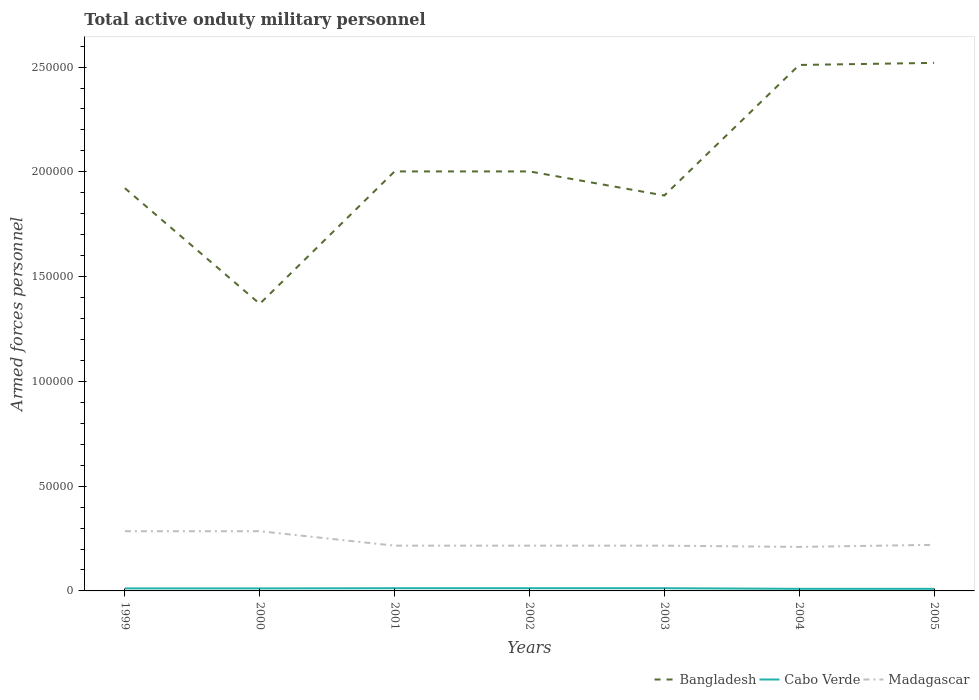Is the number of lines equal to the number of legend labels?
Keep it short and to the point. Yes. Across all years, what is the maximum number of armed forces personnel in Bangladesh?
Ensure brevity in your answer.  1.37e+05. What is the total number of armed forces personnel in Bangladesh in the graph?
Provide a short and direct response. -5.18e+04. What is the difference between the highest and the second highest number of armed forces personnel in Madagascar?
Keep it short and to the point. 7500. Is the number of armed forces personnel in Madagascar strictly greater than the number of armed forces personnel in Bangladesh over the years?
Your answer should be compact. Yes. How many lines are there?
Make the answer very short. 3. How many years are there in the graph?
Provide a succinct answer. 7. What is the difference between two consecutive major ticks on the Y-axis?
Provide a succinct answer. 5.00e+04. How many legend labels are there?
Keep it short and to the point. 3. What is the title of the graph?
Offer a terse response. Total active onduty military personnel. Does "Uganda" appear as one of the legend labels in the graph?
Ensure brevity in your answer.  No. What is the label or title of the Y-axis?
Offer a terse response. Armed forces personnel. What is the Armed forces personnel in Bangladesh in 1999?
Keep it short and to the point. 1.92e+05. What is the Armed forces personnel in Cabo Verde in 1999?
Your response must be concise. 1200. What is the Armed forces personnel of Madagascar in 1999?
Give a very brief answer. 2.85e+04. What is the Armed forces personnel in Bangladesh in 2000?
Offer a terse response. 1.37e+05. What is the Armed forces personnel in Cabo Verde in 2000?
Your answer should be compact. 1200. What is the Armed forces personnel in Madagascar in 2000?
Give a very brief answer. 2.85e+04. What is the Armed forces personnel in Bangladesh in 2001?
Provide a short and direct response. 2.00e+05. What is the Armed forces personnel of Cabo Verde in 2001?
Offer a very short reply. 1300. What is the Armed forces personnel in Madagascar in 2001?
Your answer should be compact. 2.16e+04. What is the Armed forces personnel of Bangladesh in 2002?
Make the answer very short. 2.00e+05. What is the Armed forces personnel of Cabo Verde in 2002?
Your answer should be compact. 1300. What is the Armed forces personnel of Madagascar in 2002?
Your answer should be compact. 2.16e+04. What is the Armed forces personnel in Bangladesh in 2003?
Your answer should be compact. 1.89e+05. What is the Armed forces personnel in Cabo Verde in 2003?
Keep it short and to the point. 1300. What is the Armed forces personnel of Madagascar in 2003?
Your response must be concise. 2.16e+04. What is the Armed forces personnel of Bangladesh in 2004?
Ensure brevity in your answer.  2.51e+05. What is the Armed forces personnel in Cabo Verde in 2004?
Ensure brevity in your answer.  1000. What is the Armed forces personnel of Madagascar in 2004?
Make the answer very short. 2.10e+04. What is the Armed forces personnel in Bangladesh in 2005?
Provide a succinct answer. 2.52e+05. What is the Armed forces personnel in Madagascar in 2005?
Your answer should be compact. 2.20e+04. Across all years, what is the maximum Armed forces personnel of Bangladesh?
Make the answer very short. 2.52e+05. Across all years, what is the maximum Armed forces personnel of Cabo Verde?
Your answer should be compact. 1300. Across all years, what is the maximum Armed forces personnel in Madagascar?
Offer a terse response. 2.85e+04. Across all years, what is the minimum Armed forces personnel in Bangladesh?
Provide a short and direct response. 1.37e+05. Across all years, what is the minimum Armed forces personnel in Madagascar?
Your answer should be very brief. 2.10e+04. What is the total Armed forces personnel in Bangladesh in the graph?
Make the answer very short. 1.42e+06. What is the total Armed forces personnel of Cabo Verde in the graph?
Your answer should be compact. 8300. What is the total Armed forces personnel in Madagascar in the graph?
Offer a very short reply. 1.65e+05. What is the difference between the Armed forces personnel of Bangladesh in 1999 and that in 2000?
Make the answer very short. 5.52e+04. What is the difference between the Armed forces personnel in Cabo Verde in 1999 and that in 2000?
Offer a terse response. 0. What is the difference between the Armed forces personnel of Madagascar in 1999 and that in 2000?
Your answer should be very brief. 0. What is the difference between the Armed forces personnel in Bangladesh in 1999 and that in 2001?
Make the answer very short. -8000. What is the difference between the Armed forces personnel in Cabo Verde in 1999 and that in 2001?
Your response must be concise. -100. What is the difference between the Armed forces personnel in Madagascar in 1999 and that in 2001?
Give a very brief answer. 6900. What is the difference between the Armed forces personnel of Bangladesh in 1999 and that in 2002?
Provide a succinct answer. -8000. What is the difference between the Armed forces personnel in Cabo Verde in 1999 and that in 2002?
Provide a succinct answer. -100. What is the difference between the Armed forces personnel in Madagascar in 1999 and that in 2002?
Provide a short and direct response. 6900. What is the difference between the Armed forces personnel in Bangladesh in 1999 and that in 2003?
Provide a succinct answer. 3500. What is the difference between the Armed forces personnel of Cabo Verde in 1999 and that in 2003?
Offer a terse response. -100. What is the difference between the Armed forces personnel of Madagascar in 1999 and that in 2003?
Your answer should be compact. 6900. What is the difference between the Armed forces personnel of Bangladesh in 1999 and that in 2004?
Give a very brief answer. -5.88e+04. What is the difference between the Armed forces personnel in Cabo Verde in 1999 and that in 2004?
Ensure brevity in your answer.  200. What is the difference between the Armed forces personnel in Madagascar in 1999 and that in 2004?
Provide a short and direct response. 7500. What is the difference between the Armed forces personnel in Bangladesh in 1999 and that in 2005?
Your response must be concise. -5.98e+04. What is the difference between the Armed forces personnel in Cabo Verde in 1999 and that in 2005?
Keep it short and to the point. 200. What is the difference between the Armed forces personnel of Madagascar in 1999 and that in 2005?
Your answer should be compact. 6500. What is the difference between the Armed forces personnel in Bangladesh in 2000 and that in 2001?
Provide a succinct answer. -6.32e+04. What is the difference between the Armed forces personnel in Cabo Verde in 2000 and that in 2001?
Your answer should be compact. -100. What is the difference between the Armed forces personnel in Madagascar in 2000 and that in 2001?
Keep it short and to the point. 6900. What is the difference between the Armed forces personnel in Bangladesh in 2000 and that in 2002?
Offer a very short reply. -6.32e+04. What is the difference between the Armed forces personnel of Cabo Verde in 2000 and that in 2002?
Offer a very short reply. -100. What is the difference between the Armed forces personnel in Madagascar in 2000 and that in 2002?
Your response must be concise. 6900. What is the difference between the Armed forces personnel of Bangladesh in 2000 and that in 2003?
Your answer should be very brief. -5.17e+04. What is the difference between the Armed forces personnel of Cabo Verde in 2000 and that in 2003?
Your answer should be compact. -100. What is the difference between the Armed forces personnel in Madagascar in 2000 and that in 2003?
Your answer should be very brief. 6900. What is the difference between the Armed forces personnel of Bangladesh in 2000 and that in 2004?
Your answer should be compact. -1.14e+05. What is the difference between the Armed forces personnel in Cabo Verde in 2000 and that in 2004?
Offer a terse response. 200. What is the difference between the Armed forces personnel of Madagascar in 2000 and that in 2004?
Provide a succinct answer. 7500. What is the difference between the Armed forces personnel of Bangladesh in 2000 and that in 2005?
Offer a very short reply. -1.15e+05. What is the difference between the Armed forces personnel in Madagascar in 2000 and that in 2005?
Make the answer very short. 6500. What is the difference between the Armed forces personnel of Cabo Verde in 2001 and that in 2002?
Ensure brevity in your answer.  0. What is the difference between the Armed forces personnel in Madagascar in 2001 and that in 2002?
Your response must be concise. 0. What is the difference between the Armed forces personnel in Bangladesh in 2001 and that in 2003?
Offer a very short reply. 1.15e+04. What is the difference between the Armed forces personnel of Madagascar in 2001 and that in 2003?
Offer a terse response. 0. What is the difference between the Armed forces personnel of Bangladesh in 2001 and that in 2004?
Make the answer very short. -5.08e+04. What is the difference between the Armed forces personnel in Cabo Verde in 2001 and that in 2004?
Ensure brevity in your answer.  300. What is the difference between the Armed forces personnel in Madagascar in 2001 and that in 2004?
Offer a very short reply. 600. What is the difference between the Armed forces personnel of Bangladesh in 2001 and that in 2005?
Provide a succinct answer. -5.18e+04. What is the difference between the Armed forces personnel of Cabo Verde in 2001 and that in 2005?
Your answer should be very brief. 300. What is the difference between the Armed forces personnel of Madagascar in 2001 and that in 2005?
Provide a succinct answer. -400. What is the difference between the Armed forces personnel in Bangladesh in 2002 and that in 2003?
Keep it short and to the point. 1.15e+04. What is the difference between the Armed forces personnel of Madagascar in 2002 and that in 2003?
Make the answer very short. 0. What is the difference between the Armed forces personnel in Bangladesh in 2002 and that in 2004?
Your answer should be compact. -5.08e+04. What is the difference between the Armed forces personnel of Cabo Verde in 2002 and that in 2004?
Your answer should be compact. 300. What is the difference between the Armed forces personnel in Madagascar in 2002 and that in 2004?
Your response must be concise. 600. What is the difference between the Armed forces personnel in Bangladesh in 2002 and that in 2005?
Ensure brevity in your answer.  -5.18e+04. What is the difference between the Armed forces personnel of Cabo Verde in 2002 and that in 2005?
Your answer should be very brief. 300. What is the difference between the Armed forces personnel in Madagascar in 2002 and that in 2005?
Ensure brevity in your answer.  -400. What is the difference between the Armed forces personnel of Bangladesh in 2003 and that in 2004?
Your response must be concise. -6.23e+04. What is the difference between the Armed forces personnel of Cabo Verde in 2003 and that in 2004?
Offer a terse response. 300. What is the difference between the Armed forces personnel in Madagascar in 2003 and that in 2004?
Keep it short and to the point. 600. What is the difference between the Armed forces personnel in Bangladesh in 2003 and that in 2005?
Offer a very short reply. -6.33e+04. What is the difference between the Armed forces personnel in Cabo Verde in 2003 and that in 2005?
Your response must be concise. 300. What is the difference between the Armed forces personnel in Madagascar in 2003 and that in 2005?
Make the answer very short. -400. What is the difference between the Armed forces personnel in Bangladesh in 2004 and that in 2005?
Your answer should be compact. -1000. What is the difference between the Armed forces personnel in Madagascar in 2004 and that in 2005?
Ensure brevity in your answer.  -1000. What is the difference between the Armed forces personnel in Bangladesh in 1999 and the Armed forces personnel in Cabo Verde in 2000?
Make the answer very short. 1.91e+05. What is the difference between the Armed forces personnel in Bangladesh in 1999 and the Armed forces personnel in Madagascar in 2000?
Ensure brevity in your answer.  1.64e+05. What is the difference between the Armed forces personnel in Cabo Verde in 1999 and the Armed forces personnel in Madagascar in 2000?
Offer a terse response. -2.73e+04. What is the difference between the Armed forces personnel of Bangladesh in 1999 and the Armed forces personnel of Cabo Verde in 2001?
Your answer should be very brief. 1.91e+05. What is the difference between the Armed forces personnel of Bangladesh in 1999 and the Armed forces personnel of Madagascar in 2001?
Your response must be concise. 1.71e+05. What is the difference between the Armed forces personnel in Cabo Verde in 1999 and the Armed forces personnel in Madagascar in 2001?
Provide a succinct answer. -2.04e+04. What is the difference between the Armed forces personnel of Bangladesh in 1999 and the Armed forces personnel of Cabo Verde in 2002?
Your answer should be compact. 1.91e+05. What is the difference between the Armed forces personnel in Bangladesh in 1999 and the Armed forces personnel in Madagascar in 2002?
Offer a very short reply. 1.71e+05. What is the difference between the Armed forces personnel of Cabo Verde in 1999 and the Armed forces personnel of Madagascar in 2002?
Your response must be concise. -2.04e+04. What is the difference between the Armed forces personnel of Bangladesh in 1999 and the Armed forces personnel of Cabo Verde in 2003?
Your response must be concise. 1.91e+05. What is the difference between the Armed forces personnel in Bangladesh in 1999 and the Armed forces personnel in Madagascar in 2003?
Give a very brief answer. 1.71e+05. What is the difference between the Armed forces personnel in Cabo Verde in 1999 and the Armed forces personnel in Madagascar in 2003?
Keep it short and to the point. -2.04e+04. What is the difference between the Armed forces personnel in Bangladesh in 1999 and the Armed forces personnel in Cabo Verde in 2004?
Keep it short and to the point. 1.91e+05. What is the difference between the Armed forces personnel of Bangladesh in 1999 and the Armed forces personnel of Madagascar in 2004?
Make the answer very short. 1.71e+05. What is the difference between the Armed forces personnel of Cabo Verde in 1999 and the Armed forces personnel of Madagascar in 2004?
Make the answer very short. -1.98e+04. What is the difference between the Armed forces personnel of Bangladesh in 1999 and the Armed forces personnel of Cabo Verde in 2005?
Keep it short and to the point. 1.91e+05. What is the difference between the Armed forces personnel of Bangladesh in 1999 and the Armed forces personnel of Madagascar in 2005?
Provide a succinct answer. 1.70e+05. What is the difference between the Armed forces personnel of Cabo Verde in 1999 and the Armed forces personnel of Madagascar in 2005?
Keep it short and to the point. -2.08e+04. What is the difference between the Armed forces personnel in Bangladesh in 2000 and the Armed forces personnel in Cabo Verde in 2001?
Your response must be concise. 1.36e+05. What is the difference between the Armed forces personnel in Bangladesh in 2000 and the Armed forces personnel in Madagascar in 2001?
Make the answer very short. 1.15e+05. What is the difference between the Armed forces personnel in Cabo Verde in 2000 and the Armed forces personnel in Madagascar in 2001?
Your answer should be very brief. -2.04e+04. What is the difference between the Armed forces personnel in Bangladesh in 2000 and the Armed forces personnel in Cabo Verde in 2002?
Keep it short and to the point. 1.36e+05. What is the difference between the Armed forces personnel in Bangladesh in 2000 and the Armed forces personnel in Madagascar in 2002?
Offer a very short reply. 1.15e+05. What is the difference between the Armed forces personnel of Cabo Verde in 2000 and the Armed forces personnel of Madagascar in 2002?
Offer a terse response. -2.04e+04. What is the difference between the Armed forces personnel of Bangladesh in 2000 and the Armed forces personnel of Cabo Verde in 2003?
Ensure brevity in your answer.  1.36e+05. What is the difference between the Armed forces personnel in Bangladesh in 2000 and the Armed forces personnel in Madagascar in 2003?
Your response must be concise. 1.15e+05. What is the difference between the Armed forces personnel in Cabo Verde in 2000 and the Armed forces personnel in Madagascar in 2003?
Your answer should be compact. -2.04e+04. What is the difference between the Armed forces personnel of Bangladesh in 2000 and the Armed forces personnel of Cabo Verde in 2004?
Make the answer very short. 1.36e+05. What is the difference between the Armed forces personnel of Bangladesh in 2000 and the Armed forces personnel of Madagascar in 2004?
Your answer should be very brief. 1.16e+05. What is the difference between the Armed forces personnel in Cabo Verde in 2000 and the Armed forces personnel in Madagascar in 2004?
Keep it short and to the point. -1.98e+04. What is the difference between the Armed forces personnel of Bangladesh in 2000 and the Armed forces personnel of Cabo Verde in 2005?
Your answer should be compact. 1.36e+05. What is the difference between the Armed forces personnel of Bangladesh in 2000 and the Armed forces personnel of Madagascar in 2005?
Provide a short and direct response. 1.15e+05. What is the difference between the Armed forces personnel of Cabo Verde in 2000 and the Armed forces personnel of Madagascar in 2005?
Offer a terse response. -2.08e+04. What is the difference between the Armed forces personnel in Bangladesh in 2001 and the Armed forces personnel in Cabo Verde in 2002?
Your answer should be very brief. 1.99e+05. What is the difference between the Armed forces personnel of Bangladesh in 2001 and the Armed forces personnel of Madagascar in 2002?
Your answer should be very brief. 1.79e+05. What is the difference between the Armed forces personnel in Cabo Verde in 2001 and the Armed forces personnel in Madagascar in 2002?
Keep it short and to the point. -2.03e+04. What is the difference between the Armed forces personnel of Bangladesh in 2001 and the Armed forces personnel of Cabo Verde in 2003?
Give a very brief answer. 1.99e+05. What is the difference between the Armed forces personnel of Bangladesh in 2001 and the Armed forces personnel of Madagascar in 2003?
Offer a terse response. 1.79e+05. What is the difference between the Armed forces personnel of Cabo Verde in 2001 and the Armed forces personnel of Madagascar in 2003?
Provide a succinct answer. -2.03e+04. What is the difference between the Armed forces personnel of Bangladesh in 2001 and the Armed forces personnel of Cabo Verde in 2004?
Make the answer very short. 1.99e+05. What is the difference between the Armed forces personnel of Bangladesh in 2001 and the Armed forces personnel of Madagascar in 2004?
Your answer should be very brief. 1.79e+05. What is the difference between the Armed forces personnel in Cabo Verde in 2001 and the Armed forces personnel in Madagascar in 2004?
Offer a terse response. -1.97e+04. What is the difference between the Armed forces personnel of Bangladesh in 2001 and the Armed forces personnel of Cabo Verde in 2005?
Your response must be concise. 1.99e+05. What is the difference between the Armed forces personnel of Bangladesh in 2001 and the Armed forces personnel of Madagascar in 2005?
Make the answer very short. 1.78e+05. What is the difference between the Armed forces personnel of Cabo Verde in 2001 and the Armed forces personnel of Madagascar in 2005?
Offer a terse response. -2.07e+04. What is the difference between the Armed forces personnel of Bangladesh in 2002 and the Armed forces personnel of Cabo Verde in 2003?
Give a very brief answer. 1.99e+05. What is the difference between the Armed forces personnel of Bangladesh in 2002 and the Armed forces personnel of Madagascar in 2003?
Provide a short and direct response. 1.79e+05. What is the difference between the Armed forces personnel of Cabo Verde in 2002 and the Armed forces personnel of Madagascar in 2003?
Ensure brevity in your answer.  -2.03e+04. What is the difference between the Armed forces personnel in Bangladesh in 2002 and the Armed forces personnel in Cabo Verde in 2004?
Provide a short and direct response. 1.99e+05. What is the difference between the Armed forces personnel of Bangladesh in 2002 and the Armed forces personnel of Madagascar in 2004?
Make the answer very short. 1.79e+05. What is the difference between the Armed forces personnel in Cabo Verde in 2002 and the Armed forces personnel in Madagascar in 2004?
Your response must be concise. -1.97e+04. What is the difference between the Armed forces personnel in Bangladesh in 2002 and the Armed forces personnel in Cabo Verde in 2005?
Offer a very short reply. 1.99e+05. What is the difference between the Armed forces personnel of Bangladesh in 2002 and the Armed forces personnel of Madagascar in 2005?
Offer a very short reply. 1.78e+05. What is the difference between the Armed forces personnel in Cabo Verde in 2002 and the Armed forces personnel in Madagascar in 2005?
Offer a terse response. -2.07e+04. What is the difference between the Armed forces personnel of Bangladesh in 2003 and the Armed forces personnel of Cabo Verde in 2004?
Ensure brevity in your answer.  1.88e+05. What is the difference between the Armed forces personnel of Bangladesh in 2003 and the Armed forces personnel of Madagascar in 2004?
Offer a very short reply. 1.68e+05. What is the difference between the Armed forces personnel of Cabo Verde in 2003 and the Armed forces personnel of Madagascar in 2004?
Offer a terse response. -1.97e+04. What is the difference between the Armed forces personnel of Bangladesh in 2003 and the Armed forces personnel of Cabo Verde in 2005?
Ensure brevity in your answer.  1.88e+05. What is the difference between the Armed forces personnel of Bangladesh in 2003 and the Armed forces personnel of Madagascar in 2005?
Provide a short and direct response. 1.67e+05. What is the difference between the Armed forces personnel in Cabo Verde in 2003 and the Armed forces personnel in Madagascar in 2005?
Your response must be concise. -2.07e+04. What is the difference between the Armed forces personnel in Bangladesh in 2004 and the Armed forces personnel in Madagascar in 2005?
Provide a succinct answer. 2.29e+05. What is the difference between the Armed forces personnel of Cabo Verde in 2004 and the Armed forces personnel of Madagascar in 2005?
Provide a short and direct response. -2.10e+04. What is the average Armed forces personnel in Bangladesh per year?
Provide a succinct answer. 2.03e+05. What is the average Armed forces personnel in Cabo Verde per year?
Give a very brief answer. 1185.71. What is the average Armed forces personnel in Madagascar per year?
Make the answer very short. 2.35e+04. In the year 1999, what is the difference between the Armed forces personnel in Bangladesh and Armed forces personnel in Cabo Verde?
Give a very brief answer. 1.91e+05. In the year 1999, what is the difference between the Armed forces personnel of Bangladesh and Armed forces personnel of Madagascar?
Keep it short and to the point. 1.64e+05. In the year 1999, what is the difference between the Armed forces personnel in Cabo Verde and Armed forces personnel in Madagascar?
Your response must be concise. -2.73e+04. In the year 2000, what is the difference between the Armed forces personnel of Bangladesh and Armed forces personnel of Cabo Verde?
Ensure brevity in your answer.  1.36e+05. In the year 2000, what is the difference between the Armed forces personnel of Bangladesh and Armed forces personnel of Madagascar?
Provide a short and direct response. 1.08e+05. In the year 2000, what is the difference between the Armed forces personnel in Cabo Verde and Armed forces personnel in Madagascar?
Give a very brief answer. -2.73e+04. In the year 2001, what is the difference between the Armed forces personnel of Bangladesh and Armed forces personnel of Cabo Verde?
Your response must be concise. 1.99e+05. In the year 2001, what is the difference between the Armed forces personnel of Bangladesh and Armed forces personnel of Madagascar?
Offer a terse response. 1.79e+05. In the year 2001, what is the difference between the Armed forces personnel in Cabo Verde and Armed forces personnel in Madagascar?
Ensure brevity in your answer.  -2.03e+04. In the year 2002, what is the difference between the Armed forces personnel in Bangladesh and Armed forces personnel in Cabo Verde?
Make the answer very short. 1.99e+05. In the year 2002, what is the difference between the Armed forces personnel of Bangladesh and Armed forces personnel of Madagascar?
Keep it short and to the point. 1.79e+05. In the year 2002, what is the difference between the Armed forces personnel in Cabo Verde and Armed forces personnel in Madagascar?
Make the answer very short. -2.03e+04. In the year 2003, what is the difference between the Armed forces personnel of Bangladesh and Armed forces personnel of Cabo Verde?
Make the answer very short. 1.87e+05. In the year 2003, what is the difference between the Armed forces personnel in Bangladesh and Armed forces personnel in Madagascar?
Give a very brief answer. 1.67e+05. In the year 2003, what is the difference between the Armed forces personnel of Cabo Verde and Armed forces personnel of Madagascar?
Provide a succinct answer. -2.03e+04. In the year 2004, what is the difference between the Armed forces personnel in Bangladesh and Armed forces personnel in Madagascar?
Offer a very short reply. 2.30e+05. In the year 2005, what is the difference between the Armed forces personnel in Bangladesh and Armed forces personnel in Cabo Verde?
Your answer should be compact. 2.51e+05. In the year 2005, what is the difference between the Armed forces personnel of Bangladesh and Armed forces personnel of Madagascar?
Offer a terse response. 2.30e+05. In the year 2005, what is the difference between the Armed forces personnel in Cabo Verde and Armed forces personnel in Madagascar?
Offer a very short reply. -2.10e+04. What is the ratio of the Armed forces personnel of Bangladesh in 1999 to that in 2000?
Your answer should be very brief. 1.4. What is the ratio of the Armed forces personnel of Cabo Verde in 1999 to that in 2000?
Keep it short and to the point. 1. What is the ratio of the Armed forces personnel of Madagascar in 1999 to that in 2001?
Give a very brief answer. 1.32. What is the ratio of the Armed forces personnel in Bangladesh in 1999 to that in 2002?
Your response must be concise. 0.96. What is the ratio of the Armed forces personnel in Madagascar in 1999 to that in 2002?
Keep it short and to the point. 1.32. What is the ratio of the Armed forces personnel in Bangladesh in 1999 to that in 2003?
Ensure brevity in your answer.  1.02. What is the ratio of the Armed forces personnel in Cabo Verde in 1999 to that in 2003?
Offer a terse response. 0.92. What is the ratio of the Armed forces personnel of Madagascar in 1999 to that in 2003?
Your answer should be compact. 1.32. What is the ratio of the Armed forces personnel of Bangladesh in 1999 to that in 2004?
Offer a very short reply. 0.77. What is the ratio of the Armed forces personnel in Cabo Verde in 1999 to that in 2004?
Your response must be concise. 1.2. What is the ratio of the Armed forces personnel in Madagascar in 1999 to that in 2004?
Make the answer very short. 1.36. What is the ratio of the Armed forces personnel of Bangladesh in 1999 to that in 2005?
Your response must be concise. 0.76. What is the ratio of the Armed forces personnel in Madagascar in 1999 to that in 2005?
Provide a short and direct response. 1.3. What is the ratio of the Armed forces personnel of Bangladesh in 2000 to that in 2001?
Provide a succinct answer. 0.68. What is the ratio of the Armed forces personnel in Madagascar in 2000 to that in 2001?
Offer a terse response. 1.32. What is the ratio of the Armed forces personnel of Bangladesh in 2000 to that in 2002?
Your answer should be compact. 0.68. What is the ratio of the Armed forces personnel in Madagascar in 2000 to that in 2002?
Your answer should be very brief. 1.32. What is the ratio of the Armed forces personnel in Bangladesh in 2000 to that in 2003?
Offer a terse response. 0.73. What is the ratio of the Armed forces personnel in Cabo Verde in 2000 to that in 2003?
Keep it short and to the point. 0.92. What is the ratio of the Armed forces personnel of Madagascar in 2000 to that in 2003?
Give a very brief answer. 1.32. What is the ratio of the Armed forces personnel in Bangladesh in 2000 to that in 2004?
Your answer should be compact. 0.55. What is the ratio of the Armed forces personnel in Madagascar in 2000 to that in 2004?
Provide a short and direct response. 1.36. What is the ratio of the Armed forces personnel of Bangladesh in 2000 to that in 2005?
Provide a short and direct response. 0.54. What is the ratio of the Armed forces personnel in Cabo Verde in 2000 to that in 2005?
Provide a succinct answer. 1.2. What is the ratio of the Armed forces personnel of Madagascar in 2000 to that in 2005?
Provide a short and direct response. 1.3. What is the ratio of the Armed forces personnel of Bangladesh in 2001 to that in 2002?
Your response must be concise. 1. What is the ratio of the Armed forces personnel of Cabo Verde in 2001 to that in 2002?
Keep it short and to the point. 1. What is the ratio of the Armed forces personnel of Madagascar in 2001 to that in 2002?
Offer a terse response. 1. What is the ratio of the Armed forces personnel in Bangladesh in 2001 to that in 2003?
Your answer should be very brief. 1.06. What is the ratio of the Armed forces personnel in Madagascar in 2001 to that in 2003?
Make the answer very short. 1. What is the ratio of the Armed forces personnel in Bangladesh in 2001 to that in 2004?
Ensure brevity in your answer.  0.8. What is the ratio of the Armed forces personnel of Madagascar in 2001 to that in 2004?
Provide a short and direct response. 1.03. What is the ratio of the Armed forces personnel of Bangladesh in 2001 to that in 2005?
Provide a short and direct response. 0.79. What is the ratio of the Armed forces personnel in Cabo Verde in 2001 to that in 2005?
Provide a succinct answer. 1.3. What is the ratio of the Armed forces personnel in Madagascar in 2001 to that in 2005?
Your answer should be very brief. 0.98. What is the ratio of the Armed forces personnel of Bangladesh in 2002 to that in 2003?
Make the answer very short. 1.06. What is the ratio of the Armed forces personnel of Madagascar in 2002 to that in 2003?
Keep it short and to the point. 1. What is the ratio of the Armed forces personnel in Bangladesh in 2002 to that in 2004?
Provide a short and direct response. 0.8. What is the ratio of the Armed forces personnel of Madagascar in 2002 to that in 2004?
Offer a very short reply. 1.03. What is the ratio of the Armed forces personnel of Bangladesh in 2002 to that in 2005?
Your answer should be very brief. 0.79. What is the ratio of the Armed forces personnel of Cabo Verde in 2002 to that in 2005?
Provide a succinct answer. 1.3. What is the ratio of the Armed forces personnel of Madagascar in 2002 to that in 2005?
Provide a succinct answer. 0.98. What is the ratio of the Armed forces personnel of Bangladesh in 2003 to that in 2004?
Offer a very short reply. 0.75. What is the ratio of the Armed forces personnel of Cabo Verde in 2003 to that in 2004?
Offer a very short reply. 1.3. What is the ratio of the Armed forces personnel of Madagascar in 2003 to that in 2004?
Offer a very short reply. 1.03. What is the ratio of the Armed forces personnel in Bangladesh in 2003 to that in 2005?
Keep it short and to the point. 0.75. What is the ratio of the Armed forces personnel in Madagascar in 2003 to that in 2005?
Give a very brief answer. 0.98. What is the ratio of the Armed forces personnel in Bangladesh in 2004 to that in 2005?
Give a very brief answer. 1. What is the ratio of the Armed forces personnel of Madagascar in 2004 to that in 2005?
Your answer should be compact. 0.95. What is the difference between the highest and the second highest Armed forces personnel in Madagascar?
Offer a terse response. 0. What is the difference between the highest and the lowest Armed forces personnel of Bangladesh?
Offer a very short reply. 1.15e+05. What is the difference between the highest and the lowest Armed forces personnel in Cabo Verde?
Provide a short and direct response. 300. What is the difference between the highest and the lowest Armed forces personnel in Madagascar?
Your answer should be compact. 7500. 